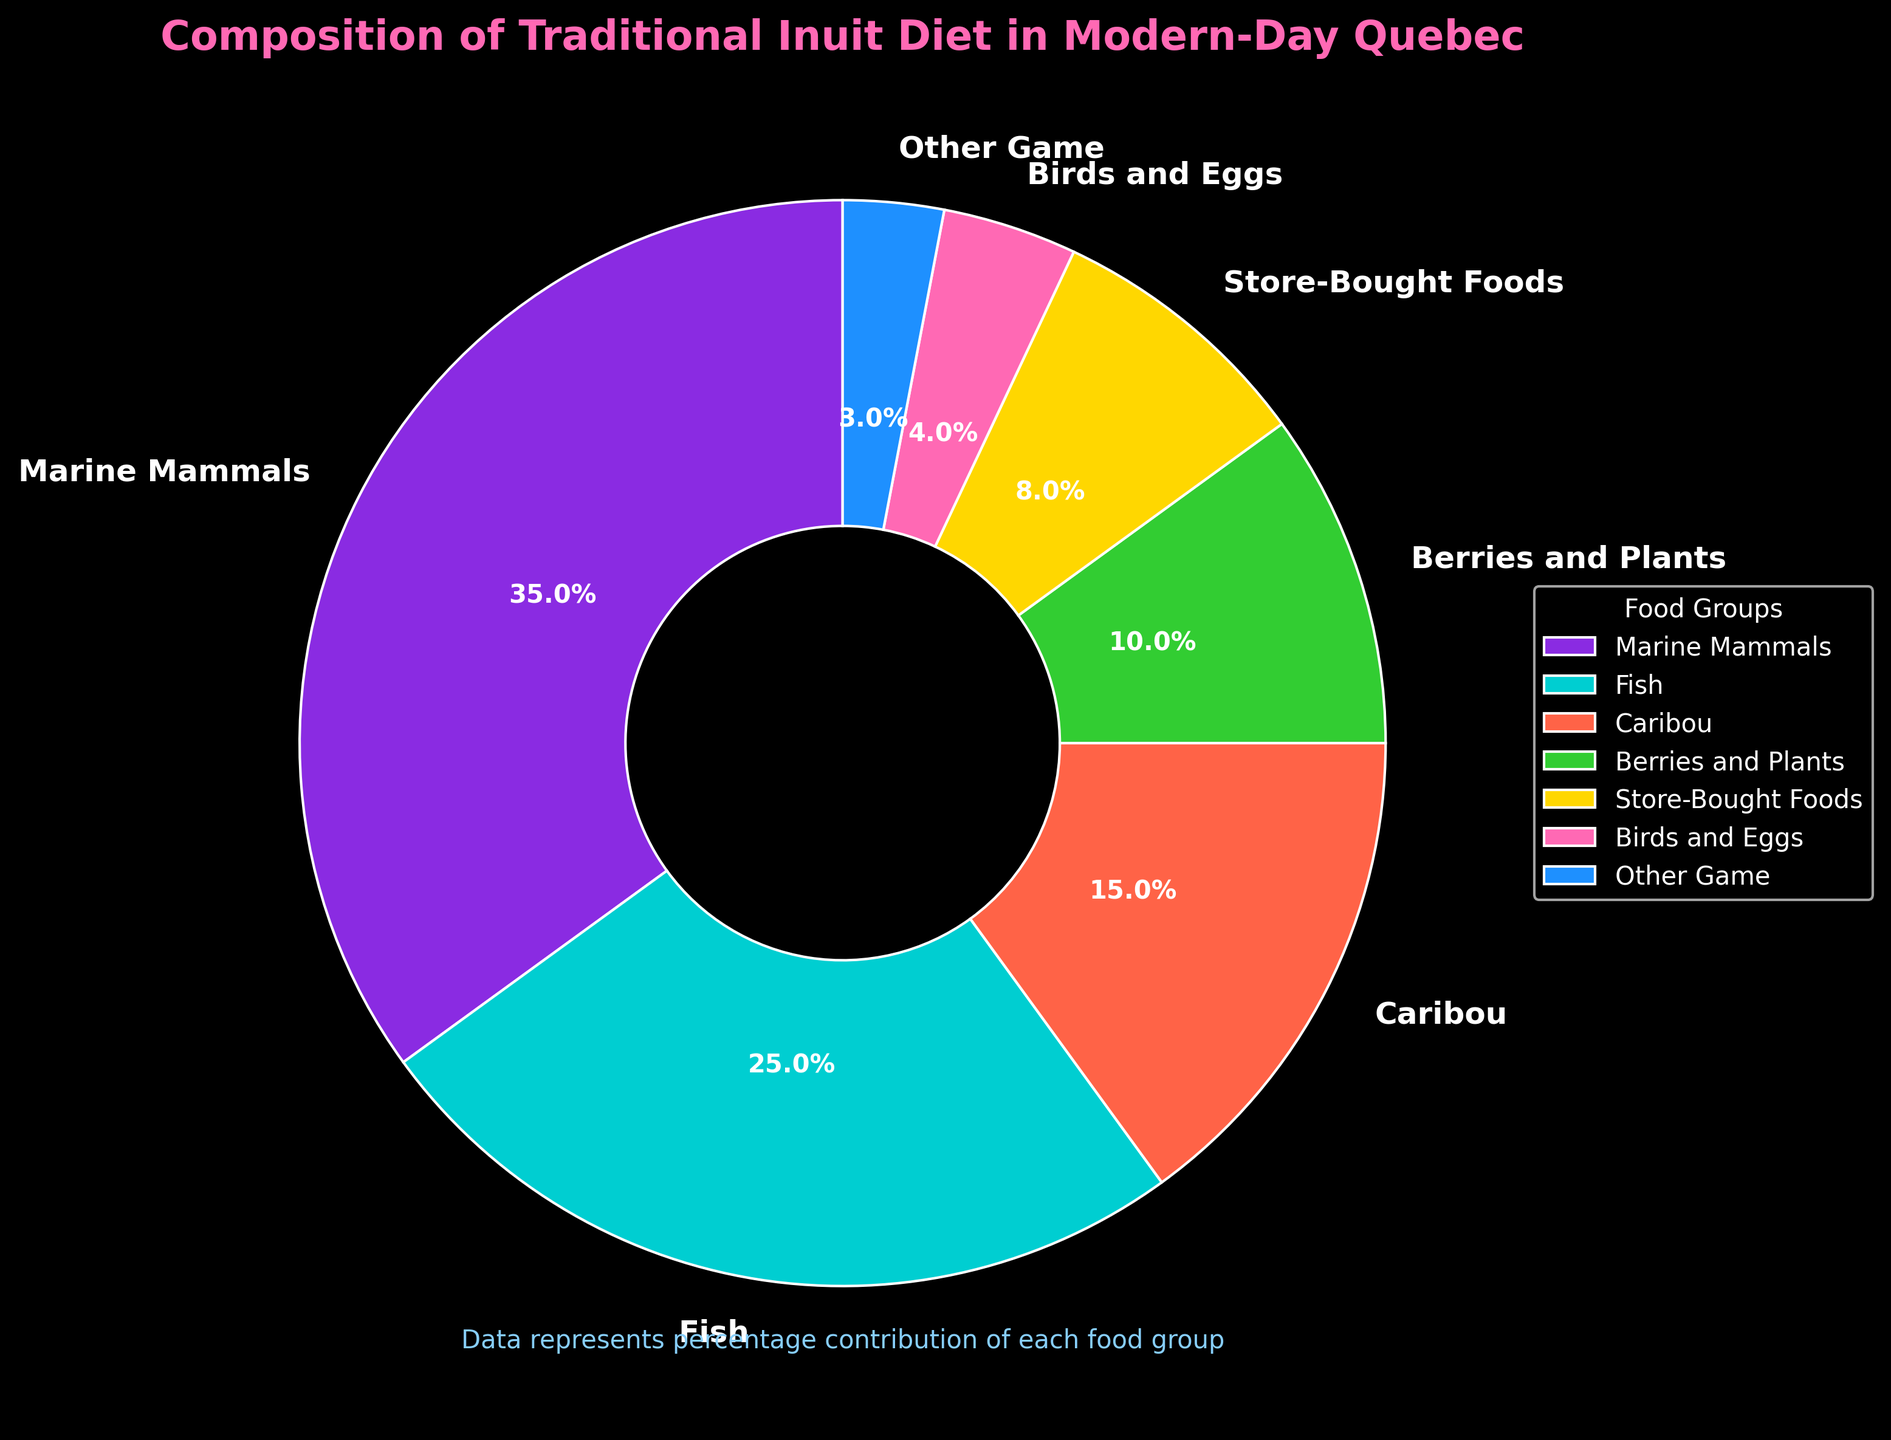Which food group contributes the highest percentage to the traditional Inuit diet in modern-day Quebec? The pie chart shows that Marine Mammals have the largest wedge, indicating the highest percentage.
Answer: Marine Mammals Which two food groups combined account for 60% of the traditional Inuit diet? Marine Mammals contribute 35% and Fish contribute 25%; together, they account for 35% + 25% = 60%.
Answer: Marine Mammals, Fish How does the percentage of Store-Bought Foods compare to that of Berries and Plants? The pie chart shows Store-Bought Foods at 8% and Berries and Plants at 10%. By comparing the values, Berries and Plants are slightly higher.
Answer: Berries and Plants are higher Which food group has the smallest contribution to the traditional Inuit diet? The wedge for Other Game is the smallest on the pie chart, indicating a 3% contribution.
Answer: Other Game What is the combined percentage of Birds and Eggs and Other Game? Birds and Eggs contribute 4% and Other Game 3%; together, they account for 4% + 3% = 7%.
Answer: 7% Which group has a greater contribution, Caribou or Store-Bought Foods, and by how much? The chart shows Caribou at 15% and Store-Bought Foods at 8%. The difference is 15% - 8% = 7%.
Answer: Caribou by 7% What percentage of the traditional Inuit diet is composed of land-based game (Caribou and Other Game)? Caribou contributes 15% and Other Game 3%; together, they make up 15% + 3% = 18%.
Answer: 18% If the wedge for Berries and Plants is green, what color represents Store-Bought Foods? According to the provided color information, Berries and Plants are green, so Store-Bought Foods should be yellow.
Answer: Yellow What food group share by visual size would be smallest if Marine Mammals were to decrease by 10%? If Marine Mammals decrease from 35% to 25%, they would be equal with Fish. The smallest percentage remains Other Game at 3%.
Answer: Other Game How does the total of Fish, Caribou, and Birds and Eggs compare to the total contribution of Marine Mammals? Fish (25%) + Caribou (15%) + Birds and Eggs (4%) equals 44%. Marine Mammals alone contribute 35%. Hence, Fish, Caribou, and Birds and Eggs together have a larger share.
Answer: Larger 